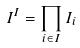<formula> <loc_0><loc_0><loc_500><loc_500>I ^ { I } = \prod _ { i \in I } I _ { i }</formula> 